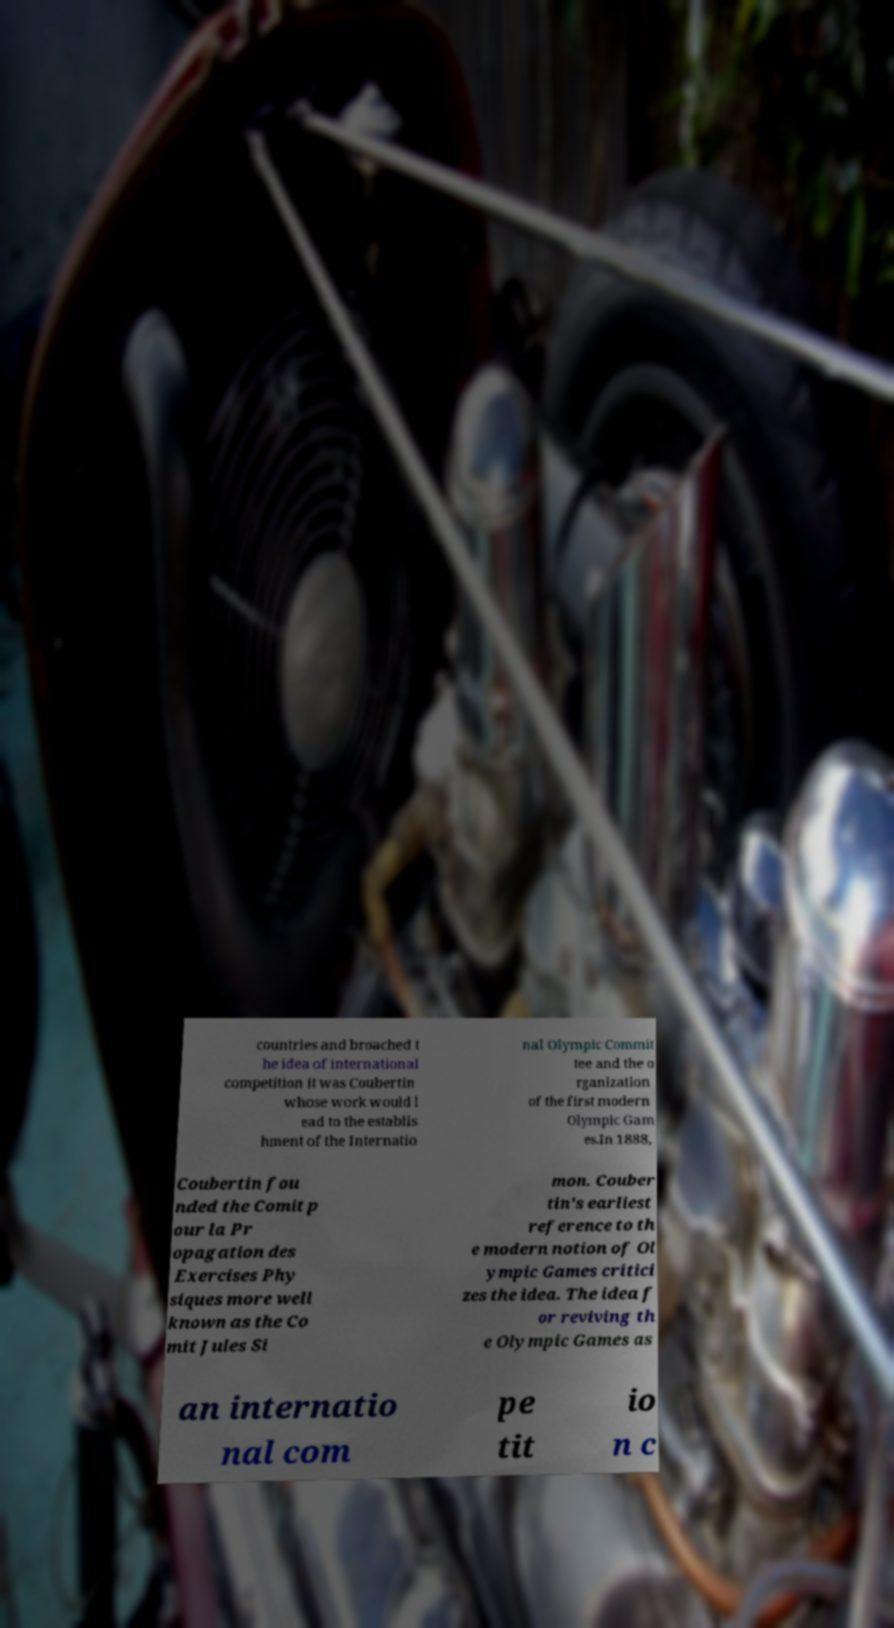Please identify and transcribe the text found in this image. countries and broached t he idea of international competition it was Coubertin whose work would l ead to the establis hment of the Internatio nal Olympic Commit tee and the o rganization of the first modern Olympic Gam es.In 1888, Coubertin fou nded the Comit p our la Pr opagation des Exercises Phy siques more well known as the Co mit Jules Si mon. Couber tin's earliest reference to th e modern notion of Ol ympic Games critici zes the idea. The idea f or reviving th e Olympic Games as an internatio nal com pe tit io n c 